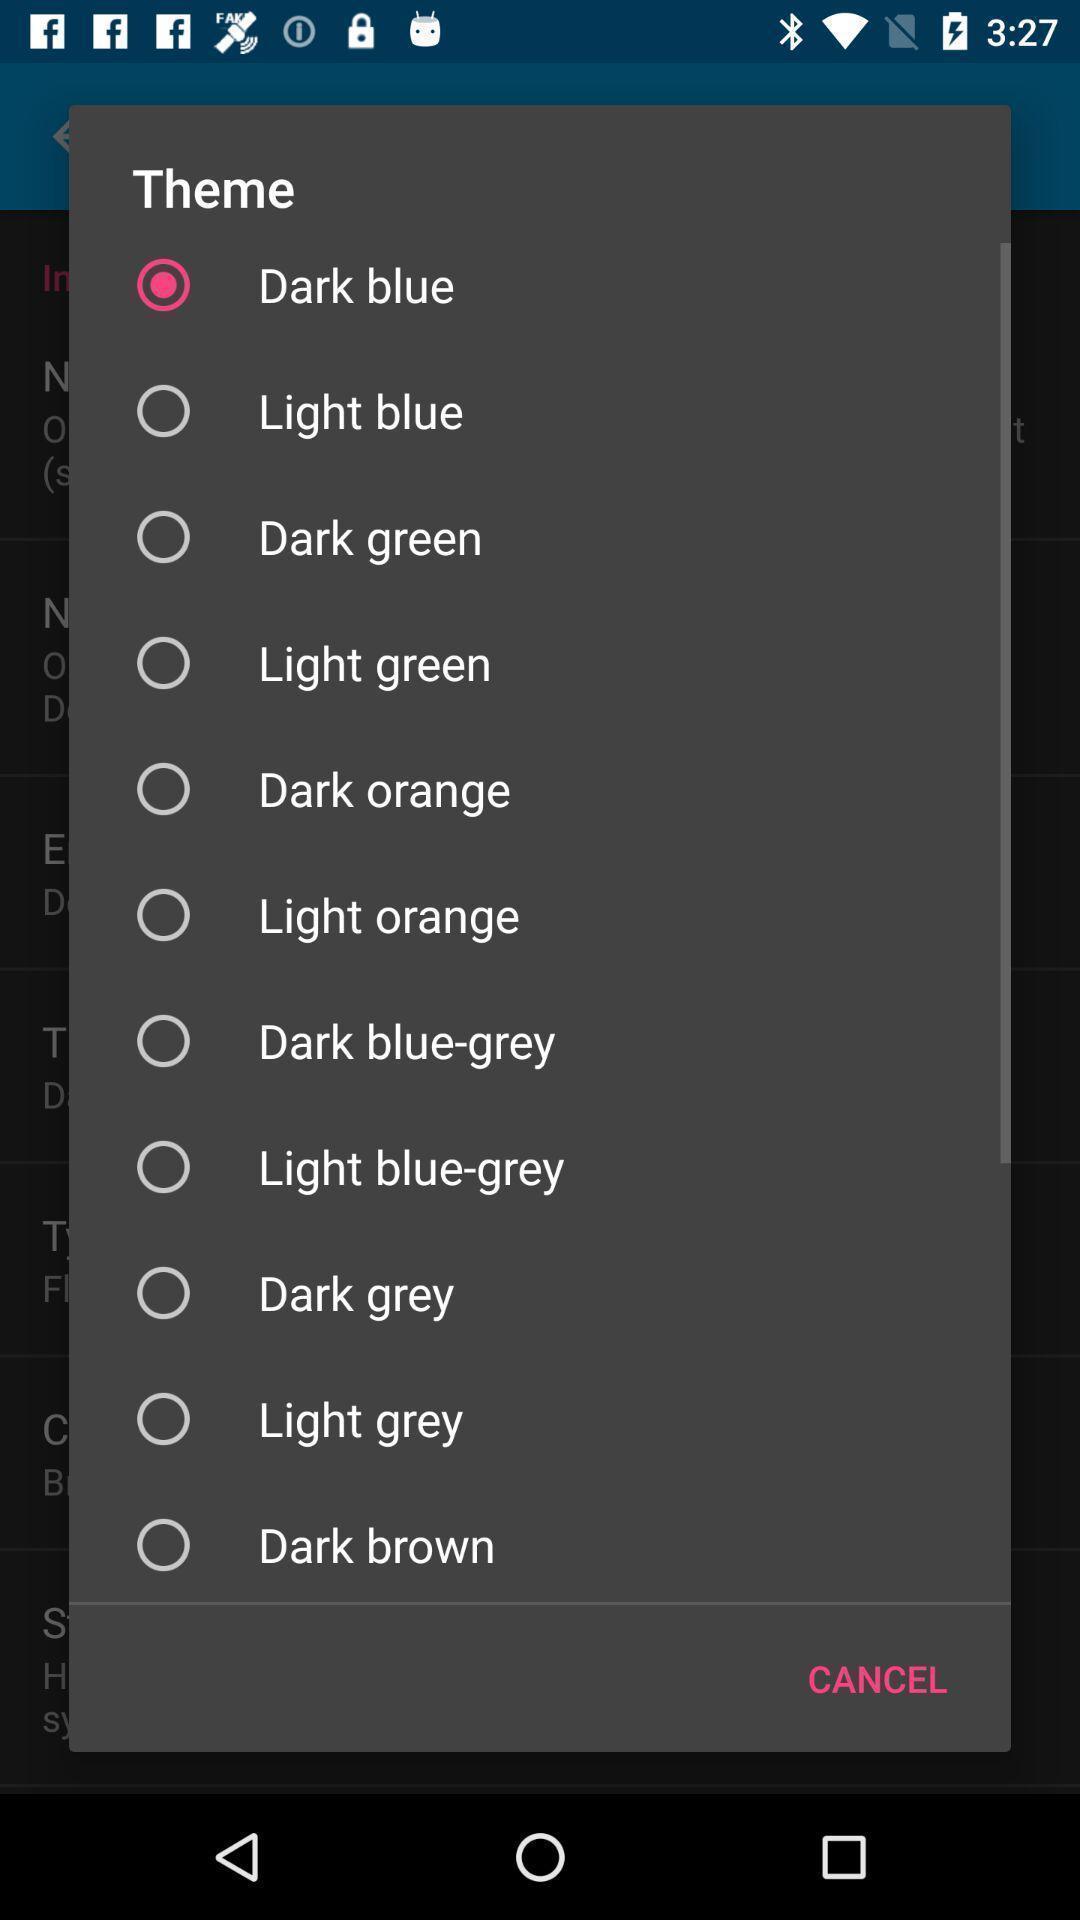Give me a summary of this screen capture. Push up displaying list of various themes. 